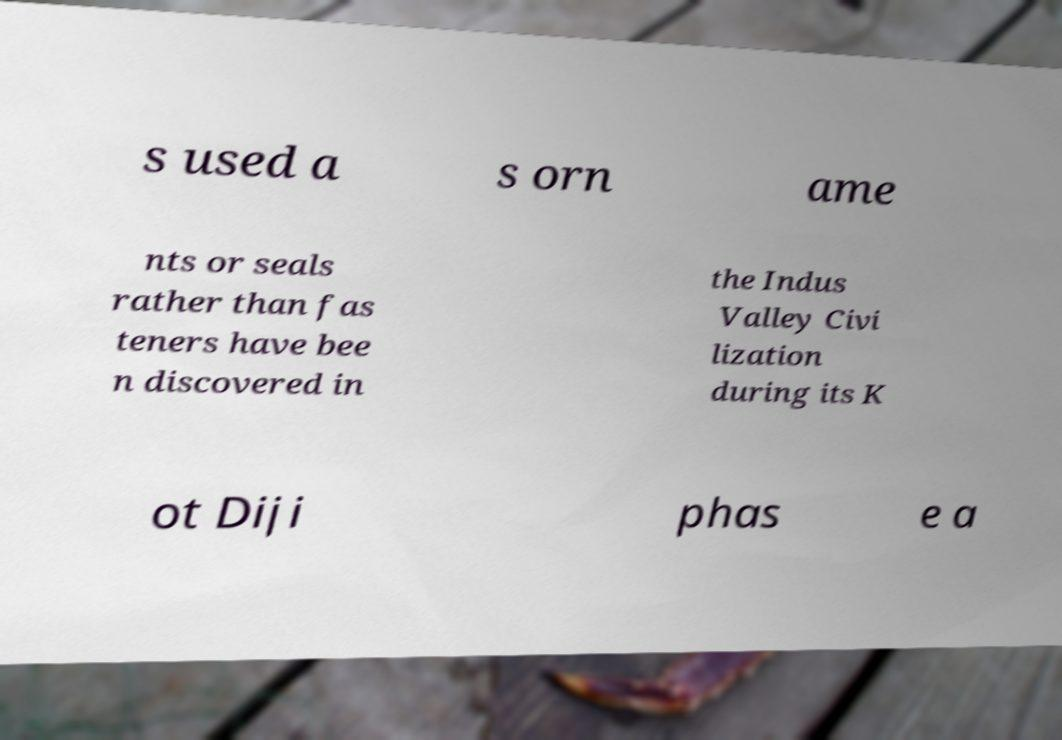I need the written content from this picture converted into text. Can you do that? s used a s orn ame nts or seals rather than fas teners have bee n discovered in the Indus Valley Civi lization during its K ot Diji phas e a 